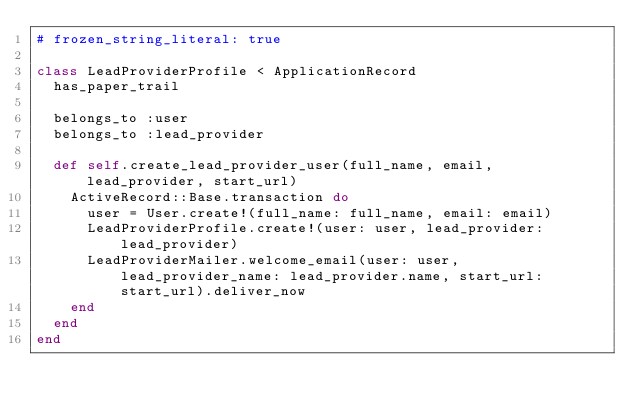<code> <loc_0><loc_0><loc_500><loc_500><_Ruby_># frozen_string_literal: true

class LeadProviderProfile < ApplicationRecord
  has_paper_trail

  belongs_to :user
  belongs_to :lead_provider

  def self.create_lead_provider_user(full_name, email, lead_provider, start_url)
    ActiveRecord::Base.transaction do
      user = User.create!(full_name: full_name, email: email)
      LeadProviderProfile.create!(user: user, lead_provider: lead_provider)
      LeadProviderMailer.welcome_email(user: user, lead_provider_name: lead_provider.name, start_url: start_url).deliver_now
    end
  end
end
</code> 